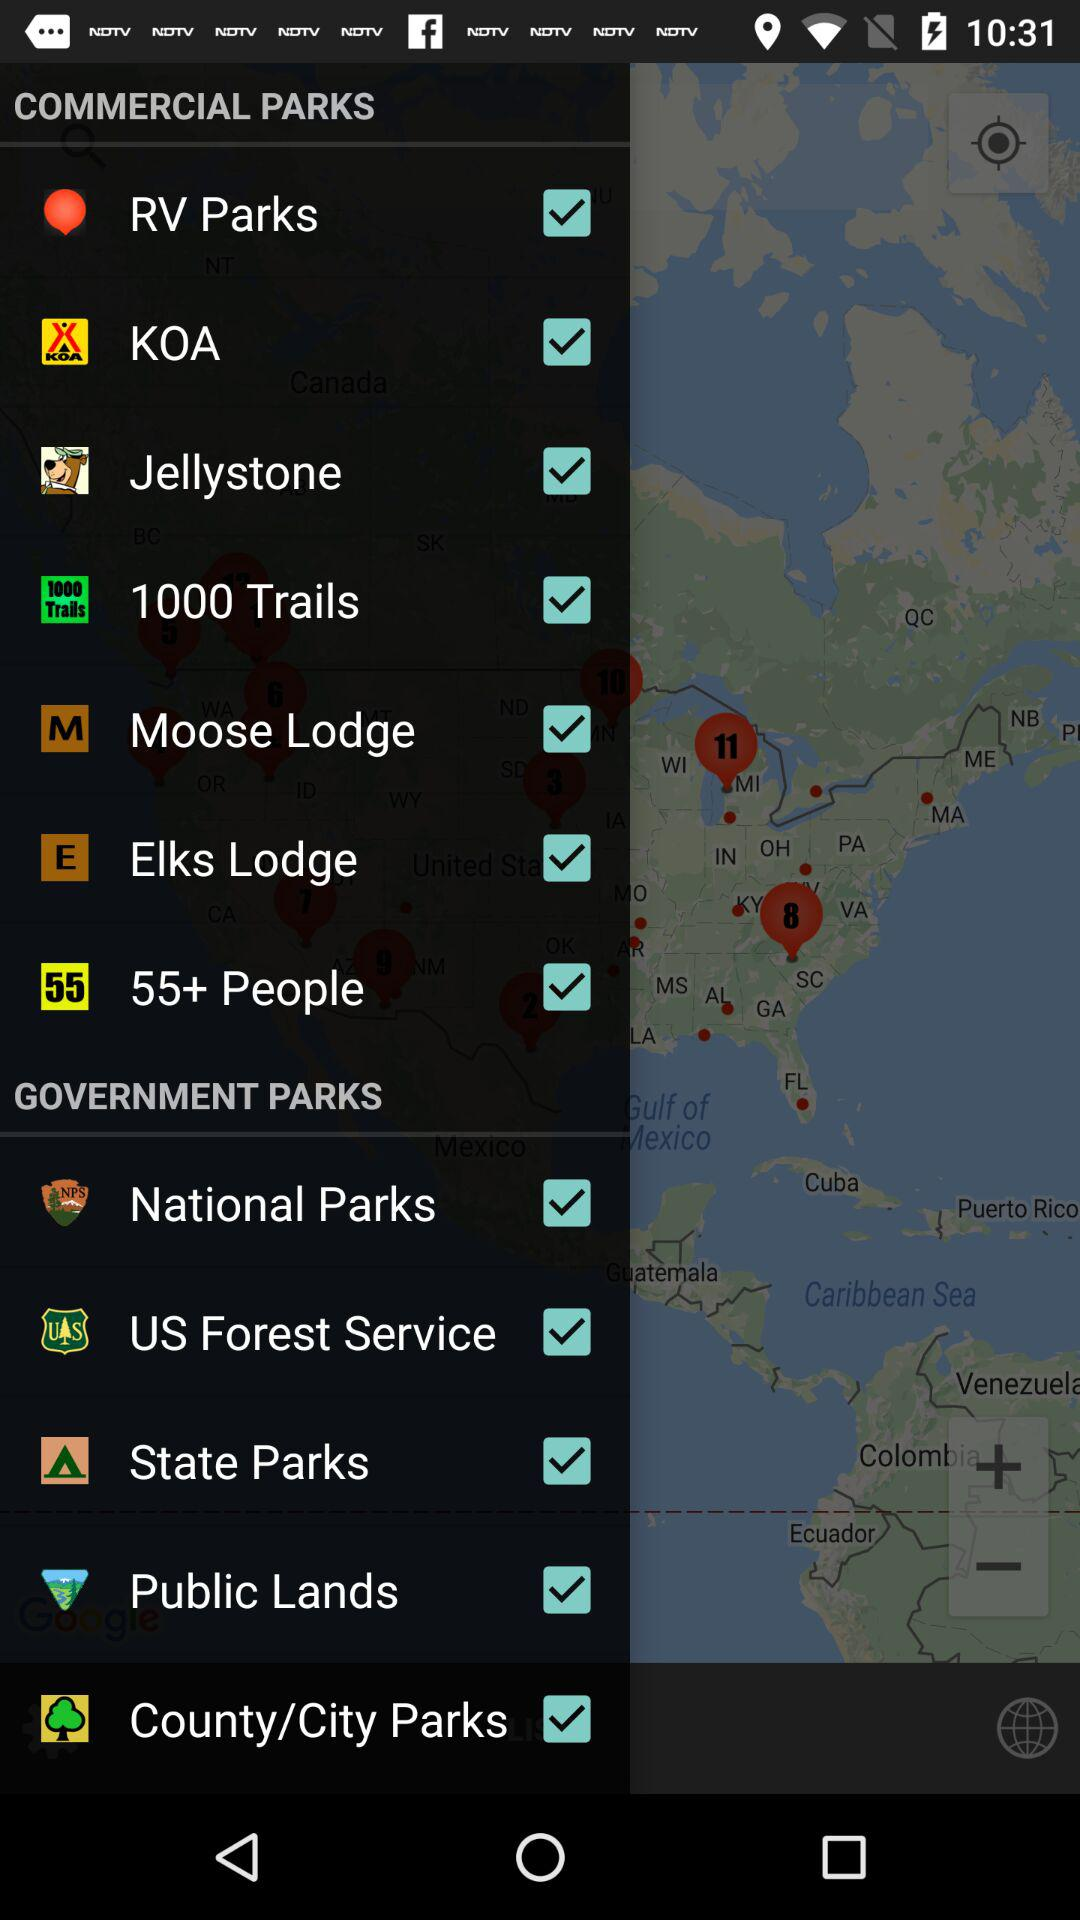Which are the selected Government Parks? The selected options are "National Parks", "US Forest Service", "State Parks", "Public Lands" and "County/City Parks". 